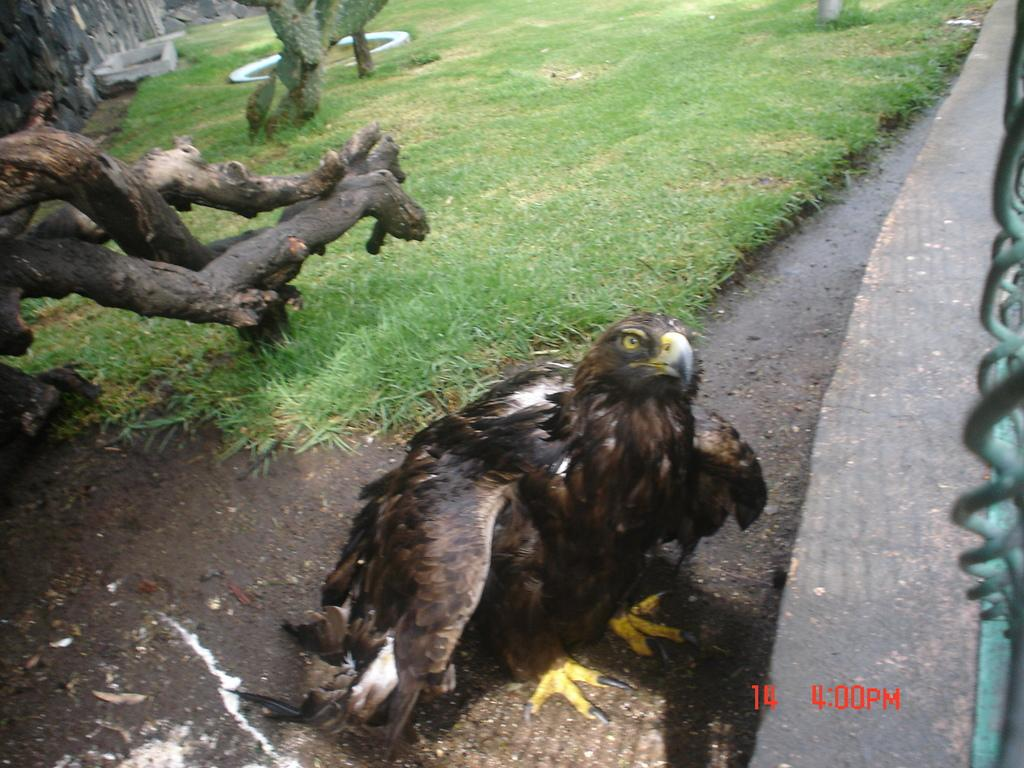What can be seen on the right side of the image? There is fencing and a platform on the right side of the image. What is present in the foreground of the image? In the foreground, there is a tree, branches, an eagle, soil, and grass. What is visible in the background of the image? In the background, there is grass, a wall, and other objects. Is there a kite flying in the image? There is no kite present in the image. How does the eagle react to the earthquake in the image? There is no earthquake present in the image, so the eagle's reaction cannot be determined. 